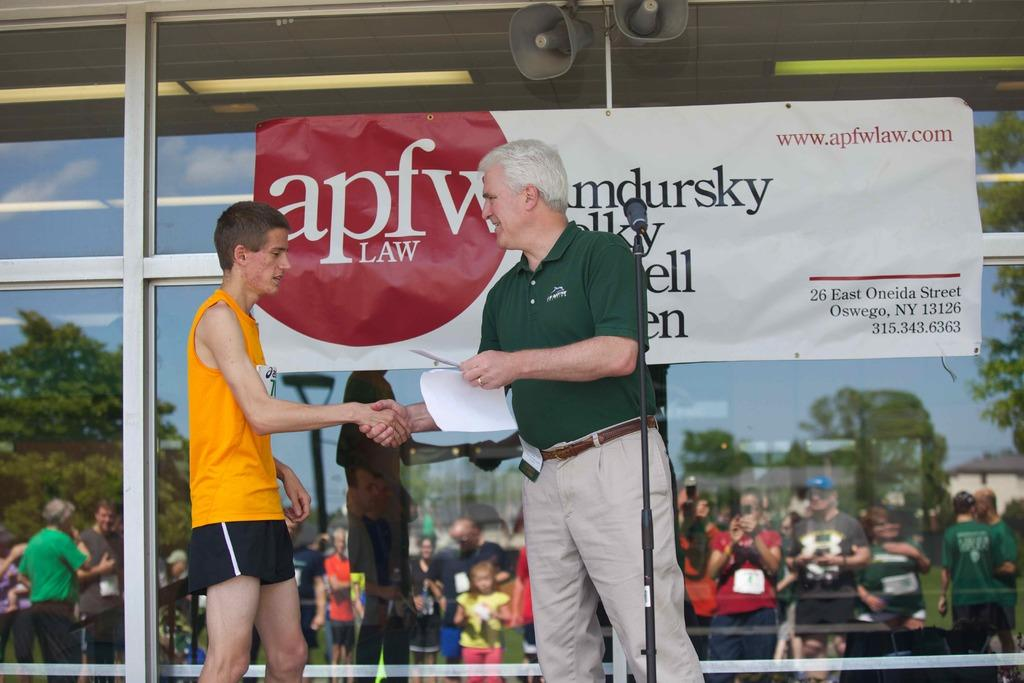<image>
Write a terse but informative summary of the picture. A man shakes a young male's hand at apfw law. 